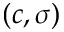<formula> <loc_0><loc_0><loc_500><loc_500>( c , \sigma )</formula> 